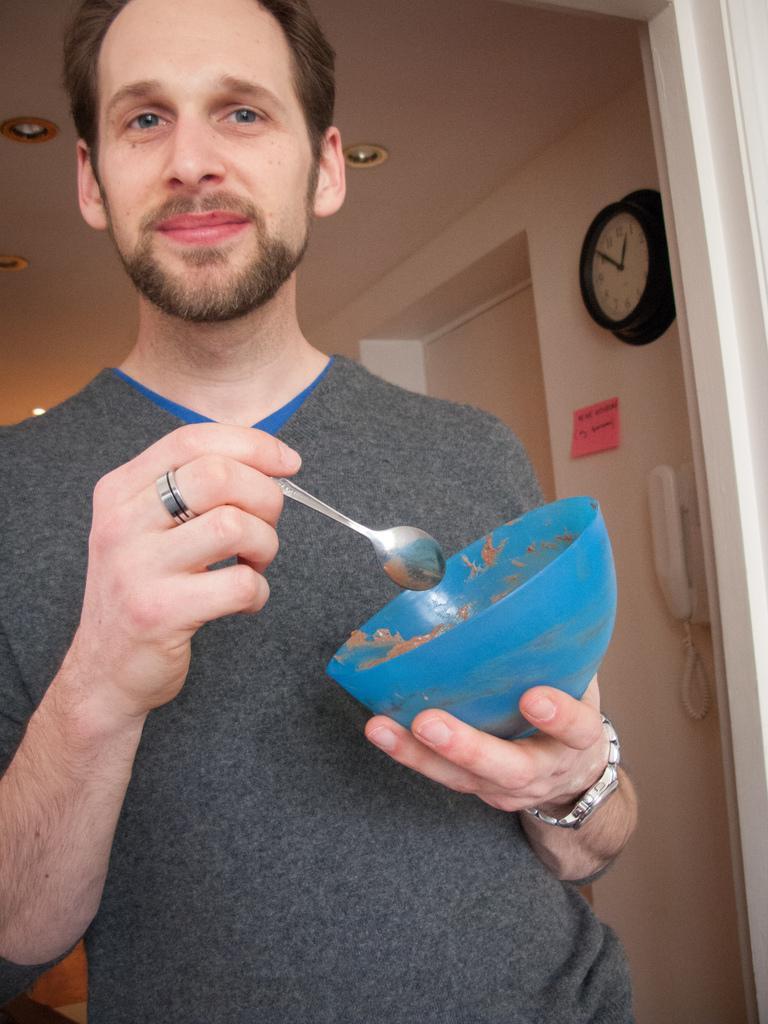Could you give a brief overview of what you see in this image? This image is clicked inside a building. There is a man standing and eating in a bowl. He is wearing a gray t-shirt. To the right, there is a wall on which a wall clock and telephone are fixed. To the right, there is a door. 